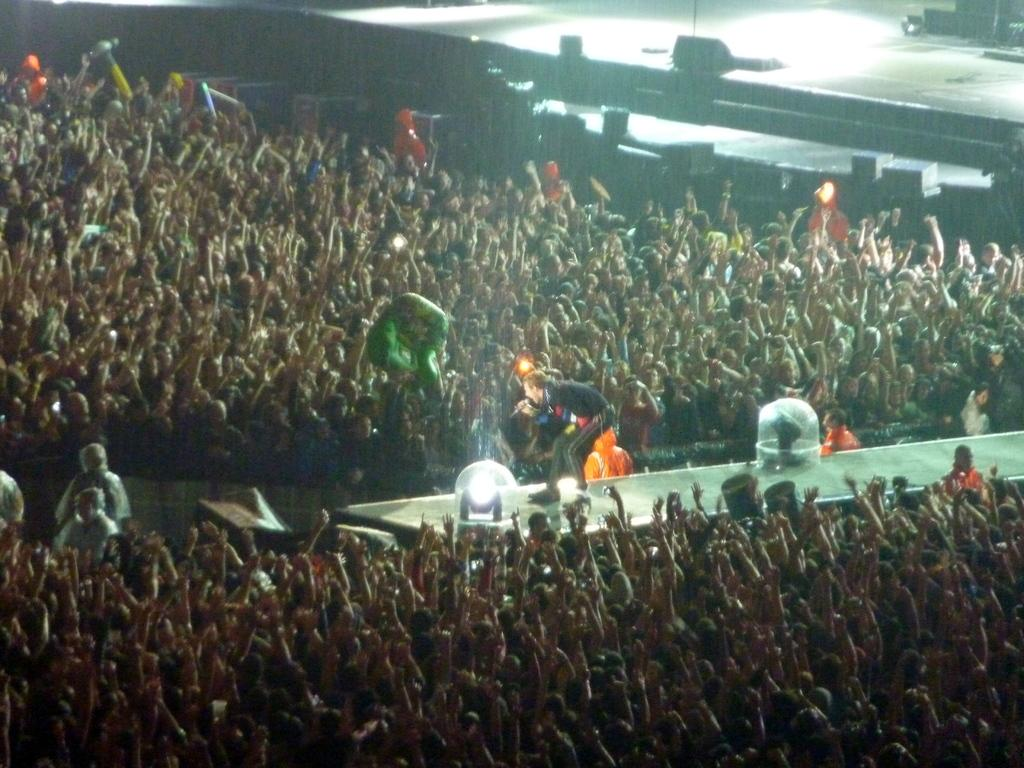How many people are in the group visible in the image? There is a group of persons in the image, but the exact number cannot be determined from the provided facts. What color are some of the objects in the image? There are objects in the image that are black in color. What feature is present in the image that might aid in accessibility? There is a ramp in the image, which can provide access for people with mobility challenges. What additional feature can be seen on the ramp? There are lights on the ramp, which can improve visibility and safety. What type of rock is being used as a seat by the minister in the image? There is no minister or rock present in the image. How many cattle are visible in the image? There are no cattle present in the image. 